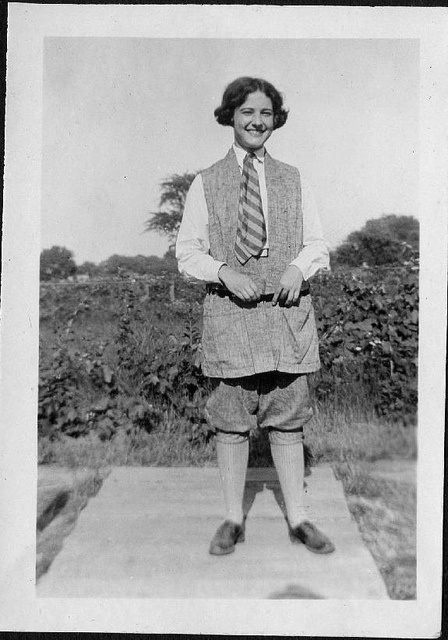Describe the objects in this image and their specific colors. I can see people in black, darkgray, gray, and lightgray tones and tie in black, darkgray, gray, and lightgray tones in this image. 